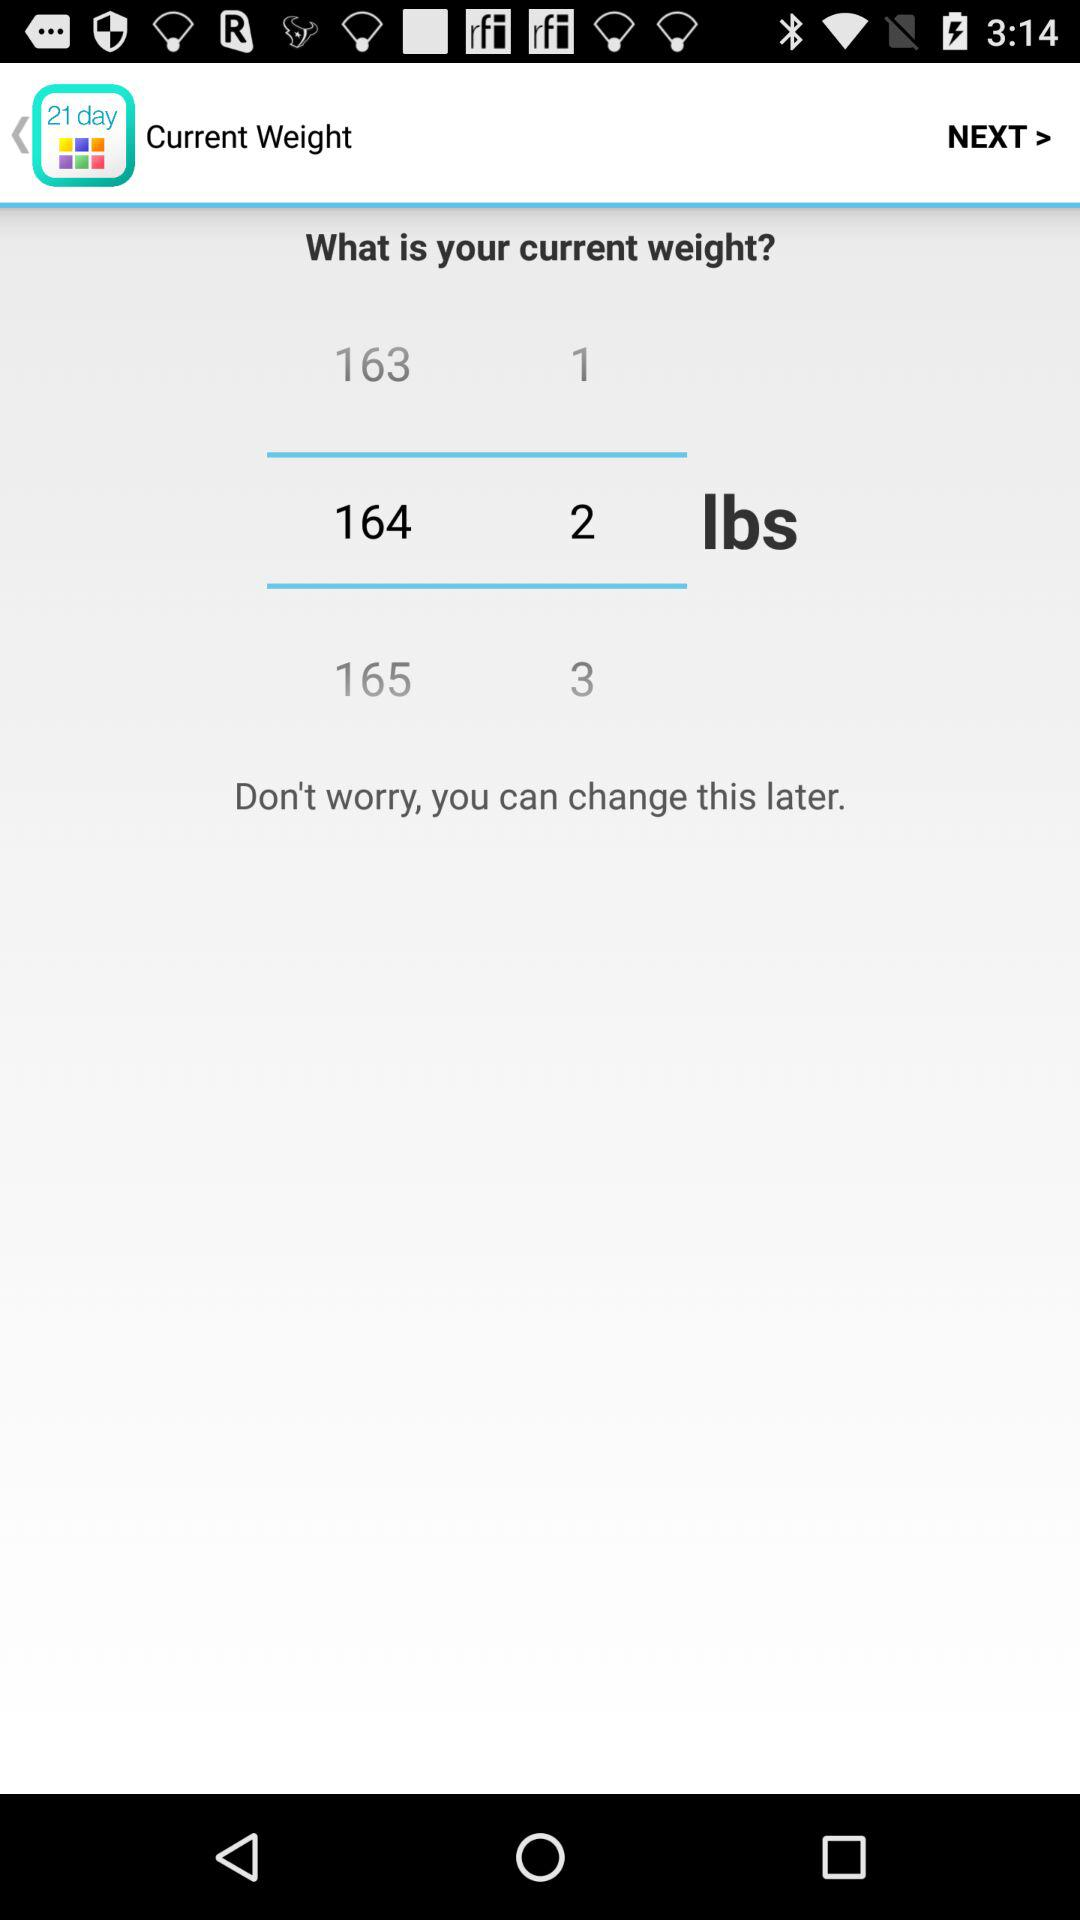How many weight options are there?
Answer the question using a single word or phrase. 3 